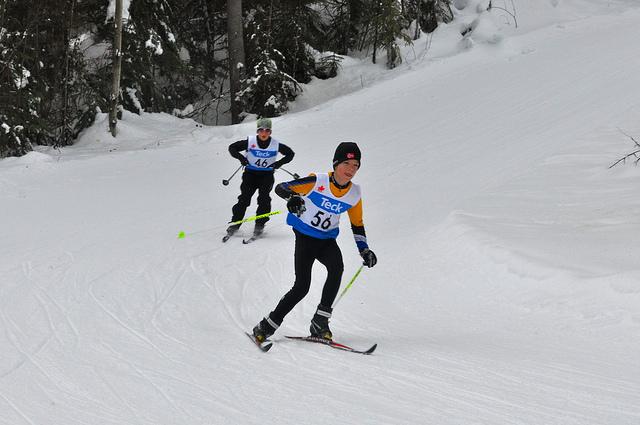Did one of the men fall?
Give a very brief answer. No. Are both people doing same activity?
Short answer required. Yes. Are they wearing protective gear?
Short answer required. No. What number is on the skier with the black hat?
Write a very short answer. 56. What is the man doing?
Answer briefly. Skiing. Are they downhill skiing?
Write a very short answer. Yes. How deep is the snow to the left of the ski pole?
Be succinct. Very deep. Are the skiers racing?
Concise answer only. Yes. 